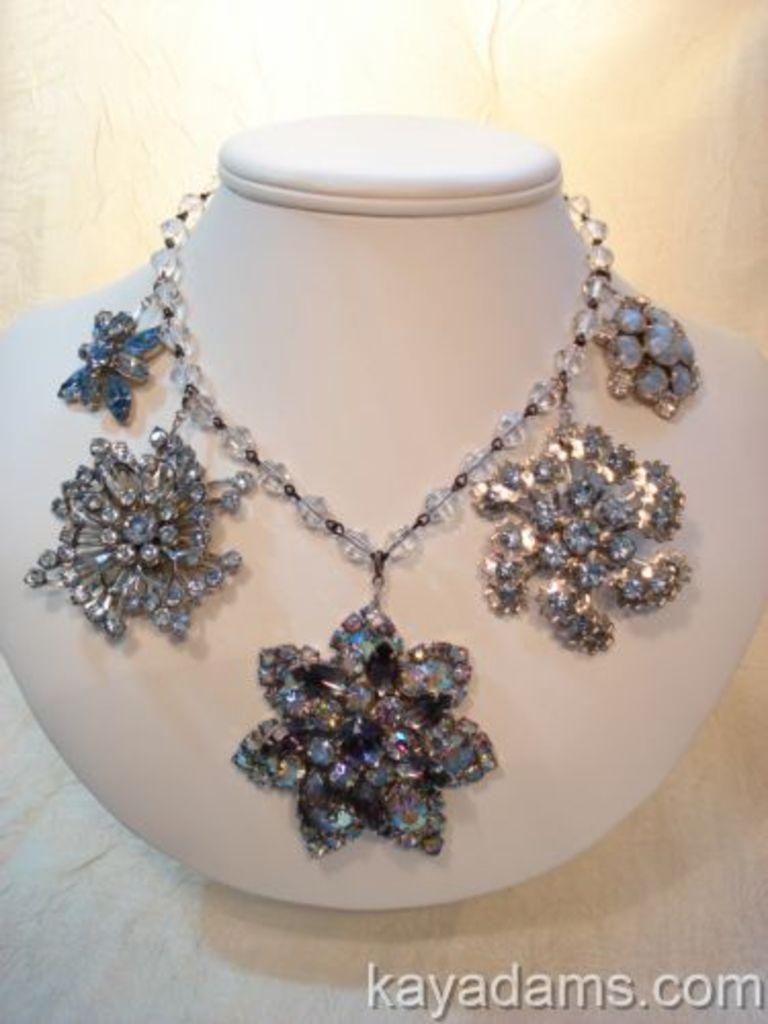Describe this image in one or two sentences. In this image there is a necklace on the mannequin neck ,and a watermark on the image. 